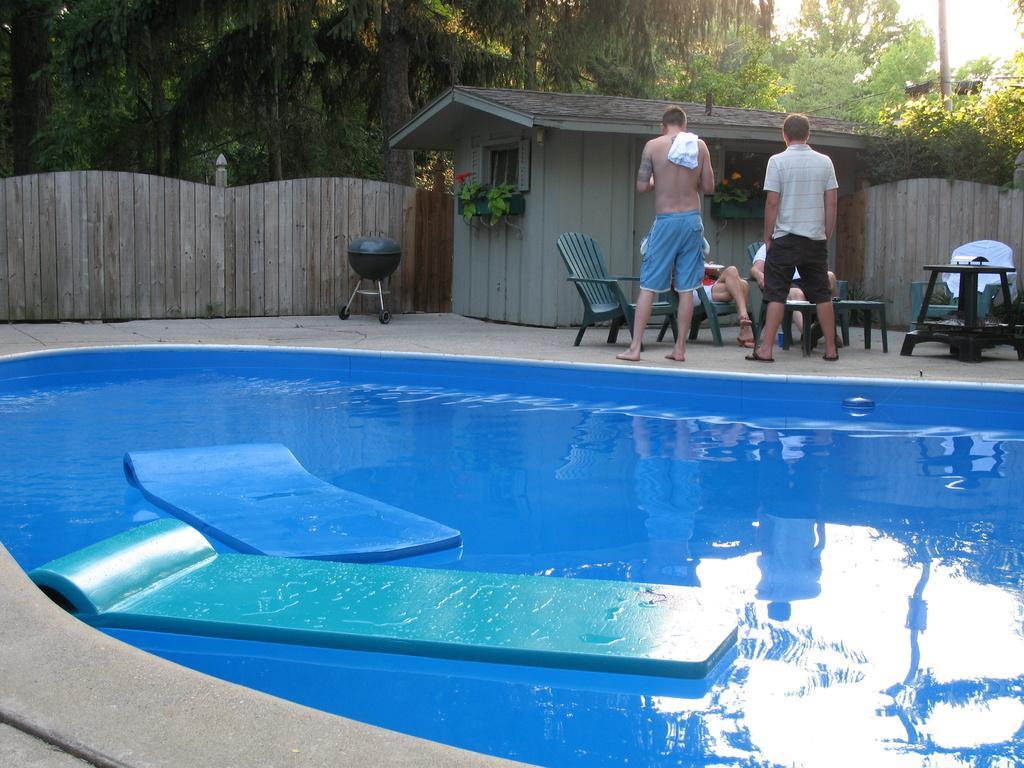Describe this image in one or two sentences. In the background we can see trees, a house. There is a plant fixed on the wall. On the left side we can see the wooden wall. We can see people sitting on the chairs. Two men are standing near to the chairs. At the bottom we can see a swimming pool and water mats. 